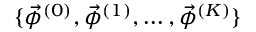<formula> <loc_0><loc_0><loc_500><loc_500>\{ \vec { \phi } ^ { ( 0 ) } , \vec { \phi } ^ { ( 1 ) } , \dots , \vec { \phi } ^ { ( K ) } \}</formula> 